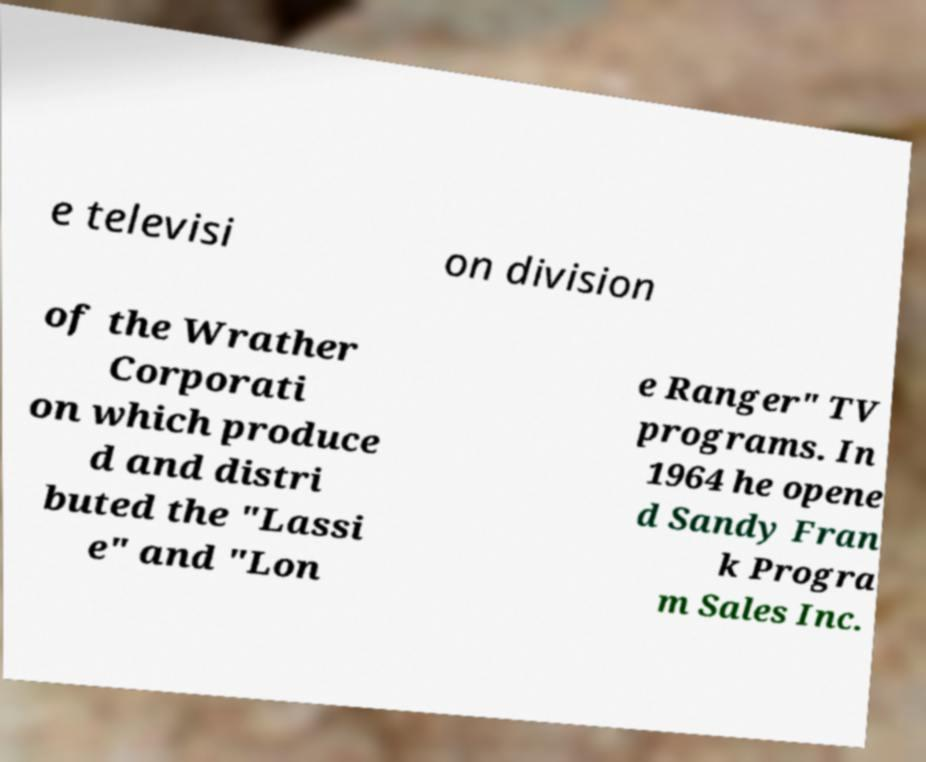For documentation purposes, I need the text within this image transcribed. Could you provide that? e televisi on division of the Wrather Corporati on which produce d and distri buted the "Lassi e" and "Lon e Ranger" TV programs. In 1964 he opene d Sandy Fran k Progra m Sales Inc. 